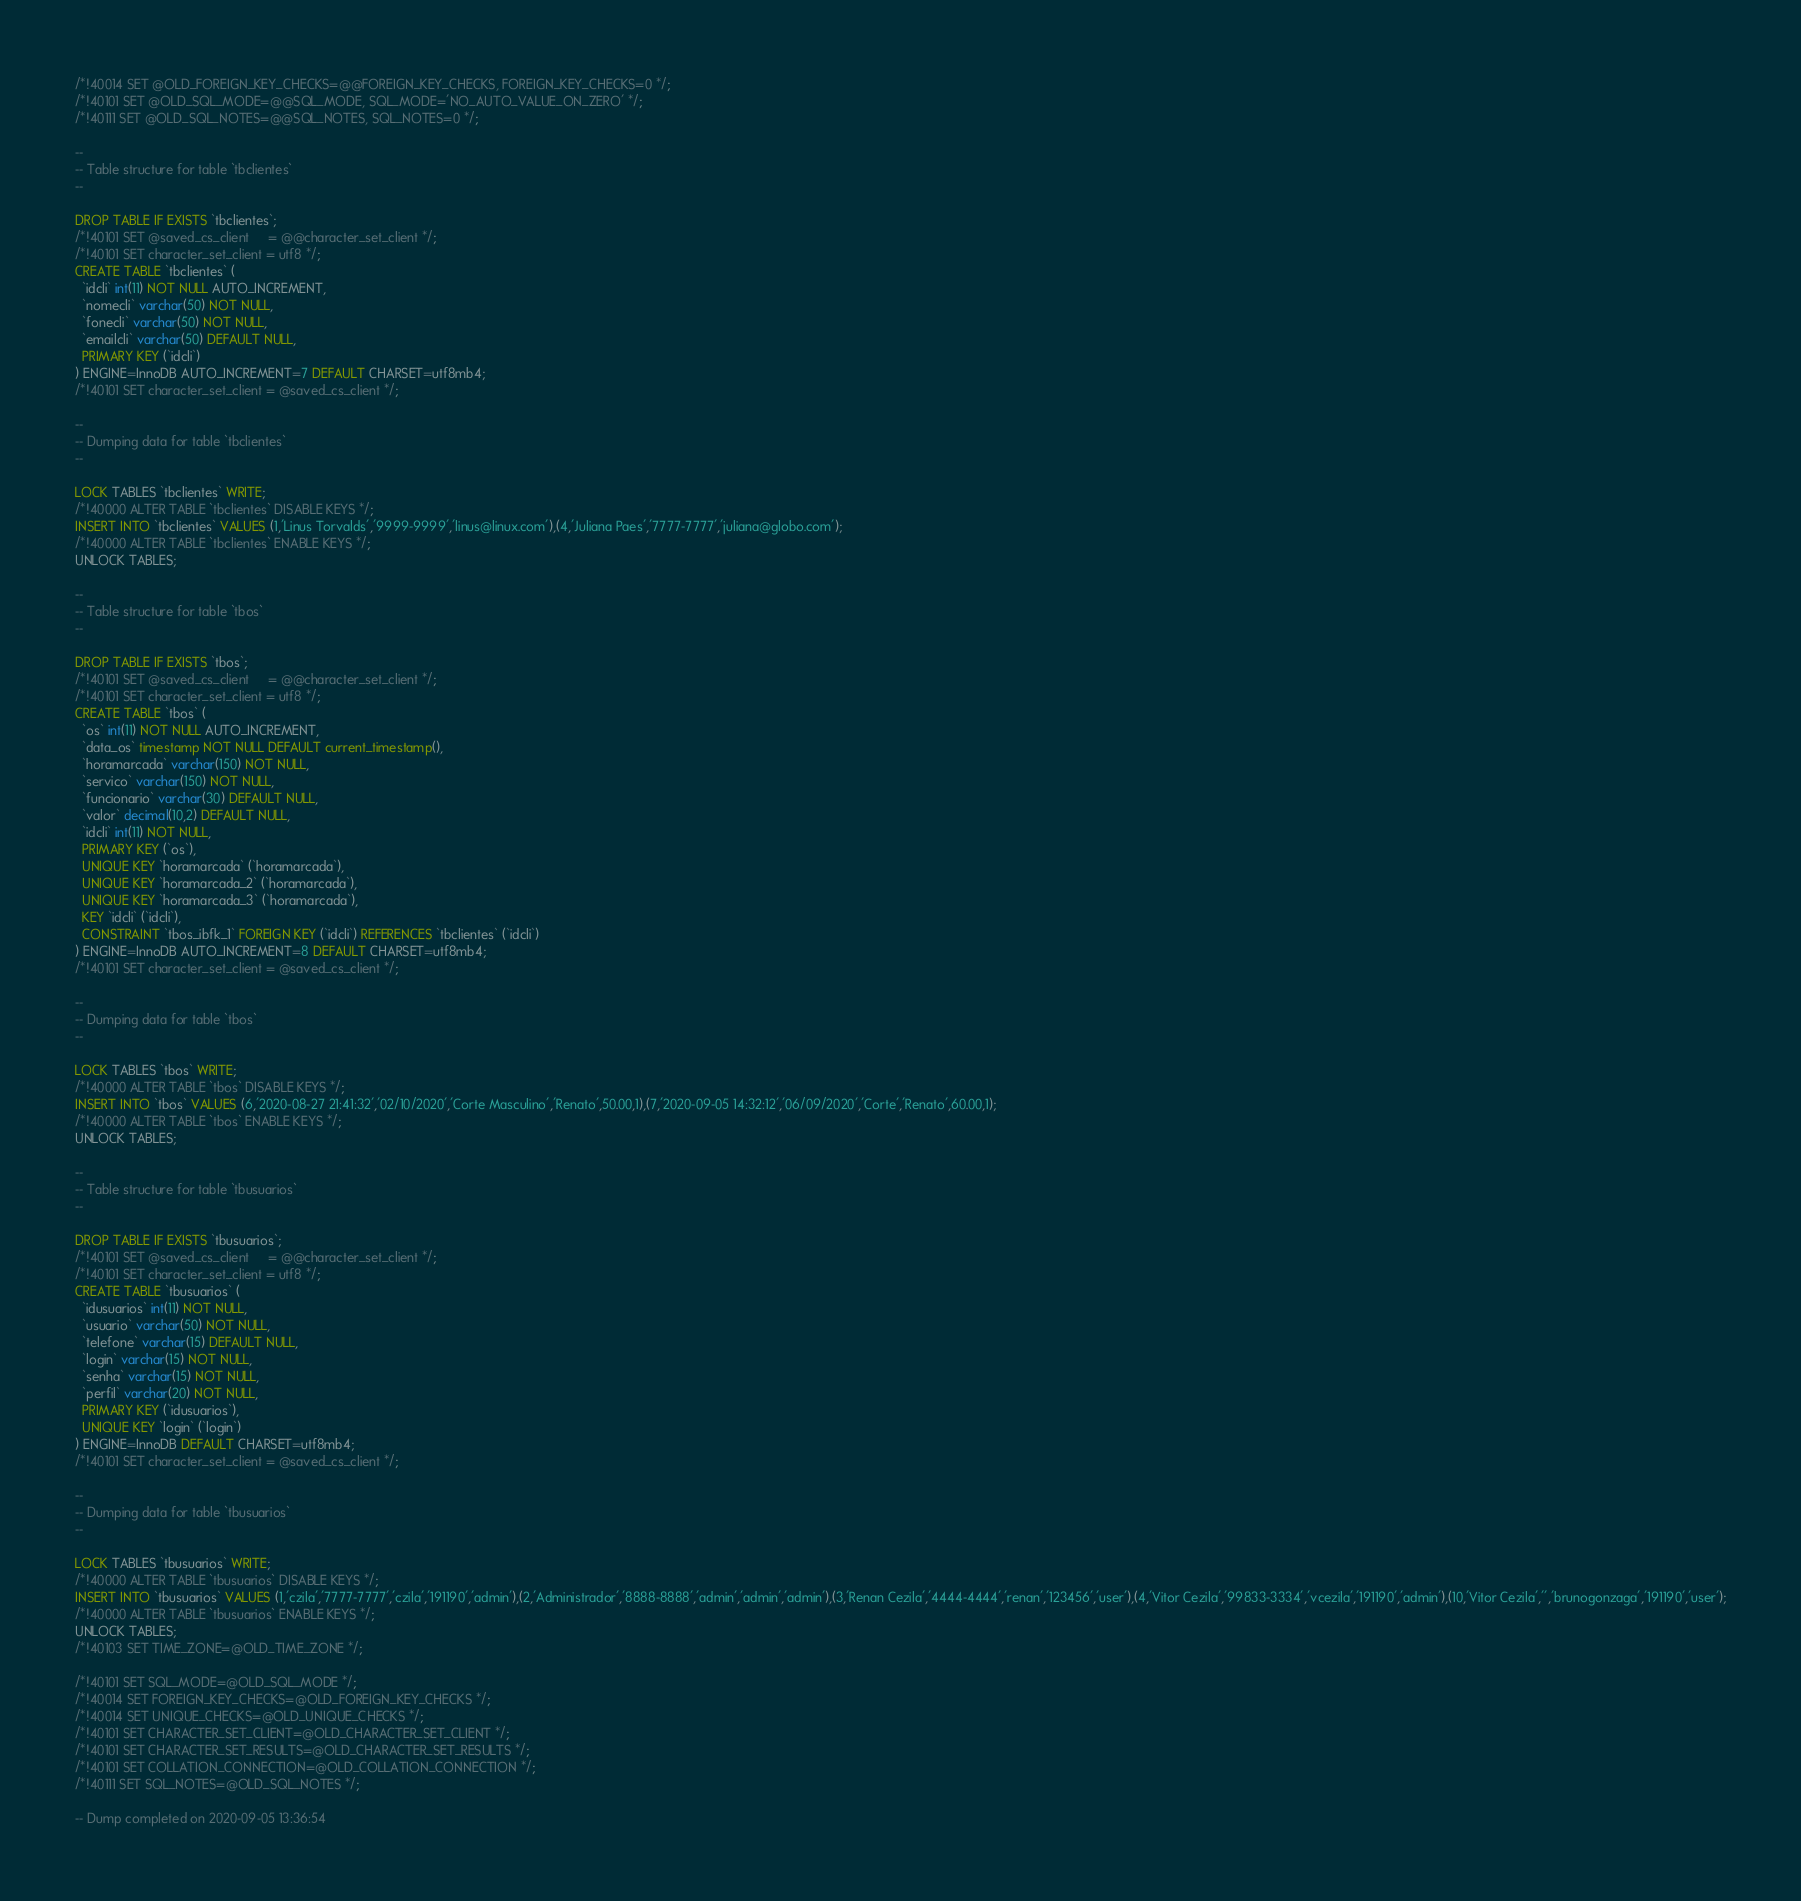Convert code to text. <code><loc_0><loc_0><loc_500><loc_500><_SQL_>/*!40014 SET @OLD_FOREIGN_KEY_CHECKS=@@FOREIGN_KEY_CHECKS, FOREIGN_KEY_CHECKS=0 */;
/*!40101 SET @OLD_SQL_MODE=@@SQL_MODE, SQL_MODE='NO_AUTO_VALUE_ON_ZERO' */;
/*!40111 SET @OLD_SQL_NOTES=@@SQL_NOTES, SQL_NOTES=0 */;

--
-- Table structure for table `tbclientes`
--

DROP TABLE IF EXISTS `tbclientes`;
/*!40101 SET @saved_cs_client     = @@character_set_client */;
/*!40101 SET character_set_client = utf8 */;
CREATE TABLE `tbclientes` (
  `idcli` int(11) NOT NULL AUTO_INCREMENT,
  `nomecli` varchar(50) NOT NULL,
  `fonecli` varchar(50) NOT NULL,
  `emailcli` varchar(50) DEFAULT NULL,
  PRIMARY KEY (`idcli`)
) ENGINE=InnoDB AUTO_INCREMENT=7 DEFAULT CHARSET=utf8mb4;
/*!40101 SET character_set_client = @saved_cs_client */;

--
-- Dumping data for table `tbclientes`
--

LOCK TABLES `tbclientes` WRITE;
/*!40000 ALTER TABLE `tbclientes` DISABLE KEYS */;
INSERT INTO `tbclientes` VALUES (1,'Linus Torvalds','9999-9999','linus@linux.com'),(4,'Juliana Paes','7777-7777','juliana@globo.com');
/*!40000 ALTER TABLE `tbclientes` ENABLE KEYS */;
UNLOCK TABLES;

--
-- Table structure for table `tbos`
--

DROP TABLE IF EXISTS `tbos`;
/*!40101 SET @saved_cs_client     = @@character_set_client */;
/*!40101 SET character_set_client = utf8 */;
CREATE TABLE `tbos` (
  `os` int(11) NOT NULL AUTO_INCREMENT,
  `data_os` timestamp NOT NULL DEFAULT current_timestamp(),
  `horamarcada` varchar(150) NOT NULL,
  `servico` varchar(150) NOT NULL,
  `funcionario` varchar(30) DEFAULT NULL,
  `valor` decimal(10,2) DEFAULT NULL,
  `idcli` int(11) NOT NULL,
  PRIMARY KEY (`os`),
  UNIQUE KEY `horamarcada` (`horamarcada`),
  UNIQUE KEY `horamarcada_2` (`horamarcada`),
  UNIQUE KEY `horamarcada_3` (`horamarcada`),
  KEY `idcli` (`idcli`),
  CONSTRAINT `tbos_ibfk_1` FOREIGN KEY (`idcli`) REFERENCES `tbclientes` (`idcli`)
) ENGINE=InnoDB AUTO_INCREMENT=8 DEFAULT CHARSET=utf8mb4;
/*!40101 SET character_set_client = @saved_cs_client */;

--
-- Dumping data for table `tbos`
--

LOCK TABLES `tbos` WRITE;
/*!40000 ALTER TABLE `tbos` DISABLE KEYS */;
INSERT INTO `tbos` VALUES (6,'2020-08-27 21:41:32','02/10/2020','Corte Masculino','Renato',50.00,1),(7,'2020-09-05 14:32:12','06/09/2020','Corte','Renato',60.00,1);
/*!40000 ALTER TABLE `tbos` ENABLE KEYS */;
UNLOCK TABLES;

--
-- Table structure for table `tbusuarios`
--

DROP TABLE IF EXISTS `tbusuarios`;
/*!40101 SET @saved_cs_client     = @@character_set_client */;
/*!40101 SET character_set_client = utf8 */;
CREATE TABLE `tbusuarios` (
  `idusuarios` int(11) NOT NULL,
  `usuario` varchar(50) NOT NULL,
  `telefone` varchar(15) DEFAULT NULL,
  `login` varchar(15) NOT NULL,
  `senha` varchar(15) NOT NULL,
  `perfil` varchar(20) NOT NULL,
  PRIMARY KEY (`idusuarios`),
  UNIQUE KEY `login` (`login`)
) ENGINE=InnoDB DEFAULT CHARSET=utf8mb4;
/*!40101 SET character_set_client = @saved_cs_client */;

--
-- Dumping data for table `tbusuarios`
--

LOCK TABLES `tbusuarios` WRITE;
/*!40000 ALTER TABLE `tbusuarios` DISABLE KEYS */;
INSERT INTO `tbusuarios` VALUES (1,'czila','7777-7777','czila','191190','admin'),(2,'Administrador','8888-8888','admin','admin','admin'),(3,'Renan Cezila','4444-4444','renan','123456','user'),(4,'Vitor Cezila','99833-3334','vcezila','191190','admin'),(10,'Vitor Cezila','','brunogonzaga','191190','user');
/*!40000 ALTER TABLE `tbusuarios` ENABLE KEYS */;
UNLOCK TABLES;
/*!40103 SET TIME_ZONE=@OLD_TIME_ZONE */;

/*!40101 SET SQL_MODE=@OLD_SQL_MODE */;
/*!40014 SET FOREIGN_KEY_CHECKS=@OLD_FOREIGN_KEY_CHECKS */;
/*!40014 SET UNIQUE_CHECKS=@OLD_UNIQUE_CHECKS */;
/*!40101 SET CHARACTER_SET_CLIENT=@OLD_CHARACTER_SET_CLIENT */;
/*!40101 SET CHARACTER_SET_RESULTS=@OLD_CHARACTER_SET_RESULTS */;
/*!40101 SET COLLATION_CONNECTION=@OLD_COLLATION_CONNECTION */;
/*!40111 SET SQL_NOTES=@OLD_SQL_NOTES */;

-- Dump completed on 2020-09-05 13:36:54
</code> 